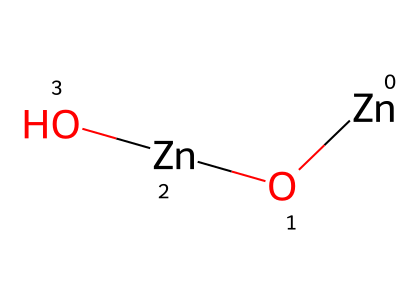What are the main elements present in this quantum dot compound? The SMILES representation shows [Zn]O[Zn]O, indicating the presence of zinc and oxygen atoms.
Answer: zinc and oxygen How many zinc atoms are in this chemical structure? By analyzing the SMILES, we see there are two [Zn] parts, indicating that there are 2 zinc atoms in total.
Answer: 2 What type of chemical bond is present between zinc and oxygen? The structure suggests that zinc and oxygen are connected by ionic bonds, as zinc typically forms positive ions that attract negatively charged oxygen ions.
Answer: ionic bonds How many total atoms does this molecular formula contain? Counting the atoms from the SMILES representation, we see 2 zinc and 2 oxygen, giving a total of 4 atoms.
Answer: 4 Is this compound hydrophobic or hydrophilic? The presence of oxygen typically suggests that the compound is hydrophilic due to the capability of oxygen to form polar interactions with water.
Answer: hydrophilic What category of nanomaterials does zinc oxide quantum dots belong to? Zinc oxide quantum dots are categorized as semiconductor nanomaterials, known for their unique optical properties and application in various fields.
Answer: semiconductor 